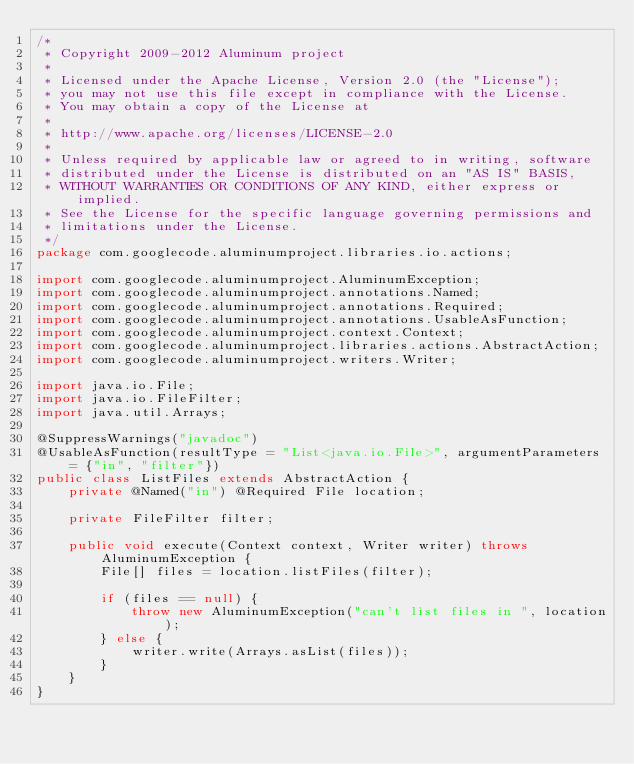Convert code to text. <code><loc_0><loc_0><loc_500><loc_500><_Java_>/*
 * Copyright 2009-2012 Aluminum project
 *
 * Licensed under the Apache License, Version 2.0 (the "License");
 * you may not use this file except in compliance with the License.
 * You may obtain a copy of the License at
 *
 * http://www.apache.org/licenses/LICENSE-2.0
 *
 * Unless required by applicable law or agreed to in writing, software
 * distributed under the License is distributed on an "AS IS" BASIS,
 * WITHOUT WARRANTIES OR CONDITIONS OF ANY KIND, either express or implied.
 * See the License for the specific language governing permissions and
 * limitations under the License.
 */
package com.googlecode.aluminumproject.libraries.io.actions;

import com.googlecode.aluminumproject.AluminumException;
import com.googlecode.aluminumproject.annotations.Named;
import com.googlecode.aluminumproject.annotations.Required;
import com.googlecode.aluminumproject.annotations.UsableAsFunction;
import com.googlecode.aluminumproject.context.Context;
import com.googlecode.aluminumproject.libraries.actions.AbstractAction;
import com.googlecode.aluminumproject.writers.Writer;

import java.io.File;
import java.io.FileFilter;
import java.util.Arrays;

@SuppressWarnings("javadoc")
@UsableAsFunction(resultType = "List<java.io.File>", argumentParameters = {"in", "filter"})
public class ListFiles extends AbstractAction {
	private @Named("in") @Required File location;

	private FileFilter filter;

	public void execute(Context context, Writer writer) throws AluminumException {
		File[] files = location.listFiles(filter);

		if (files == null) {
			throw new AluminumException("can't list files in ", location);
		} else {
			writer.write(Arrays.asList(files));
		}
	}
}</code> 